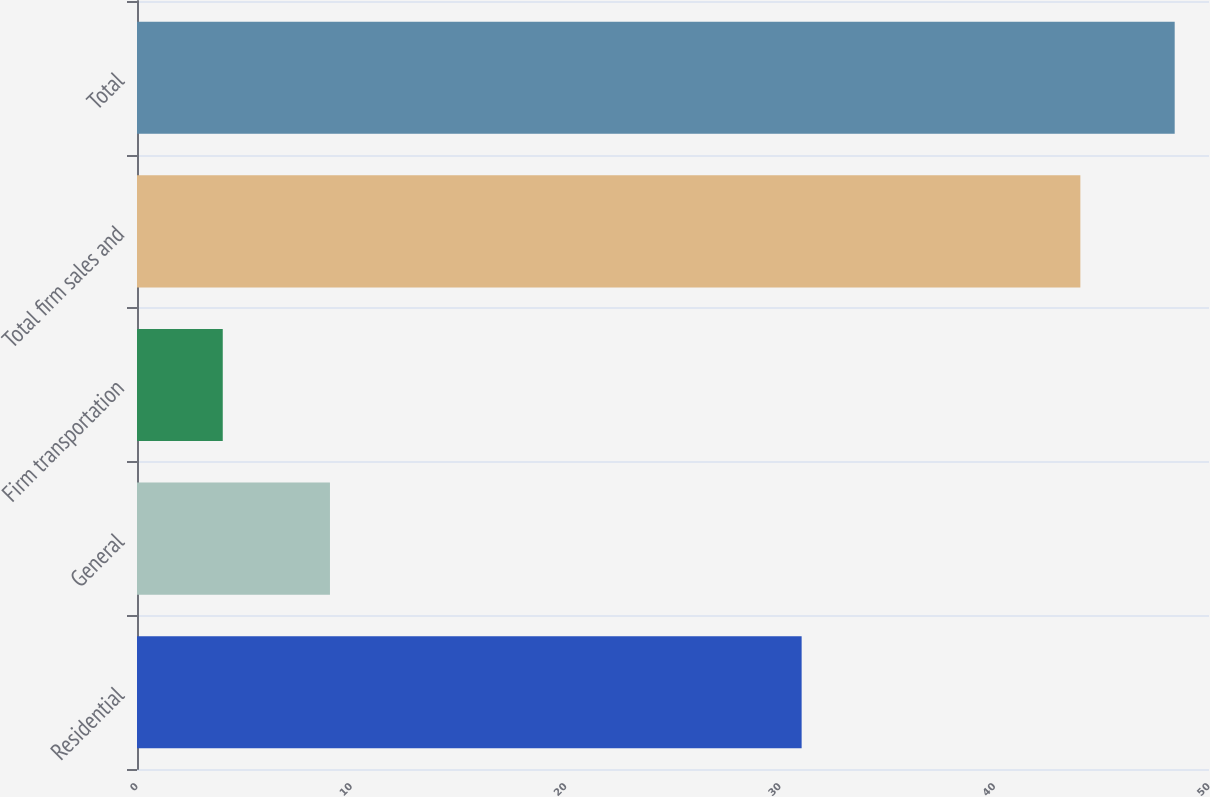<chart> <loc_0><loc_0><loc_500><loc_500><bar_chart><fcel>Residential<fcel>General<fcel>Firm transportation<fcel>Total firm sales and<fcel>Total<nl><fcel>31<fcel>9<fcel>4<fcel>44<fcel>48.4<nl></chart> 